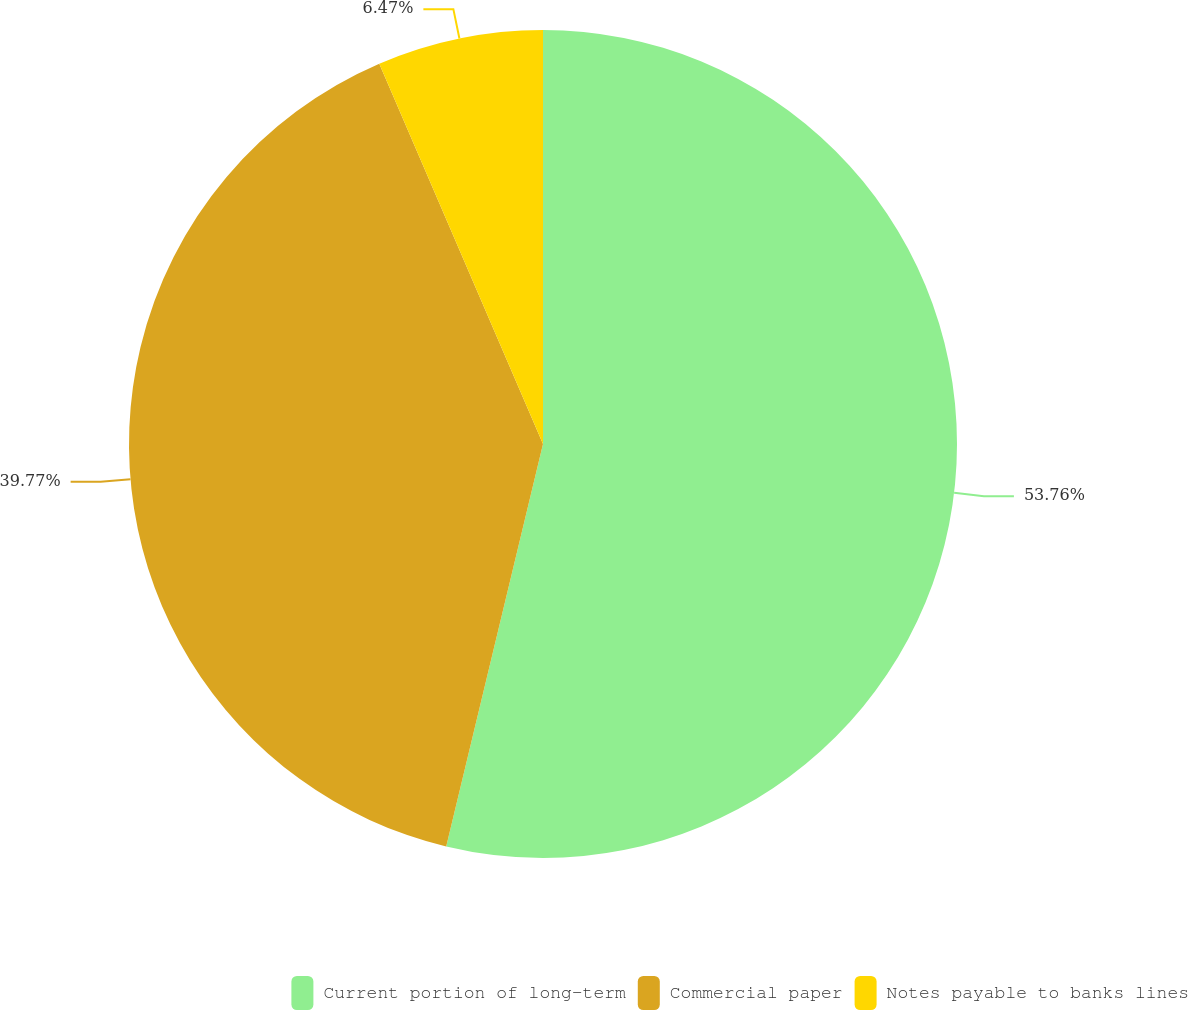<chart> <loc_0><loc_0><loc_500><loc_500><pie_chart><fcel>Current portion of long-term<fcel>Commercial paper<fcel>Notes payable to banks lines<nl><fcel>53.75%<fcel>39.77%<fcel>6.47%<nl></chart> 